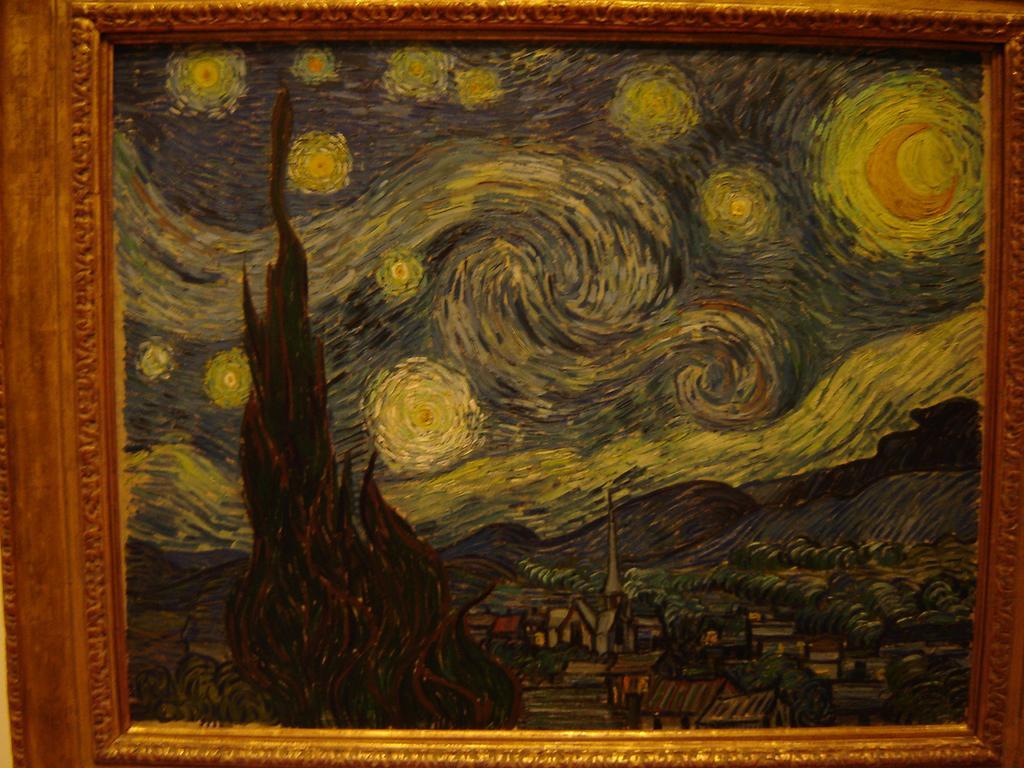Please provide a concise description of this image. In this image there is a frame and there is a painting on the frame. 